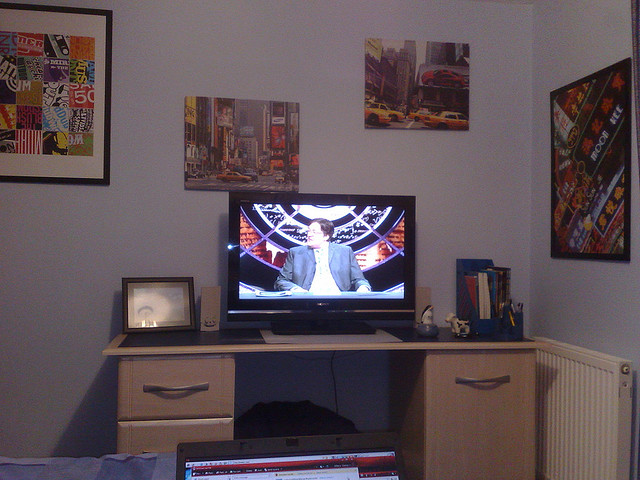Please identify all text content in this image. 50 TIER 